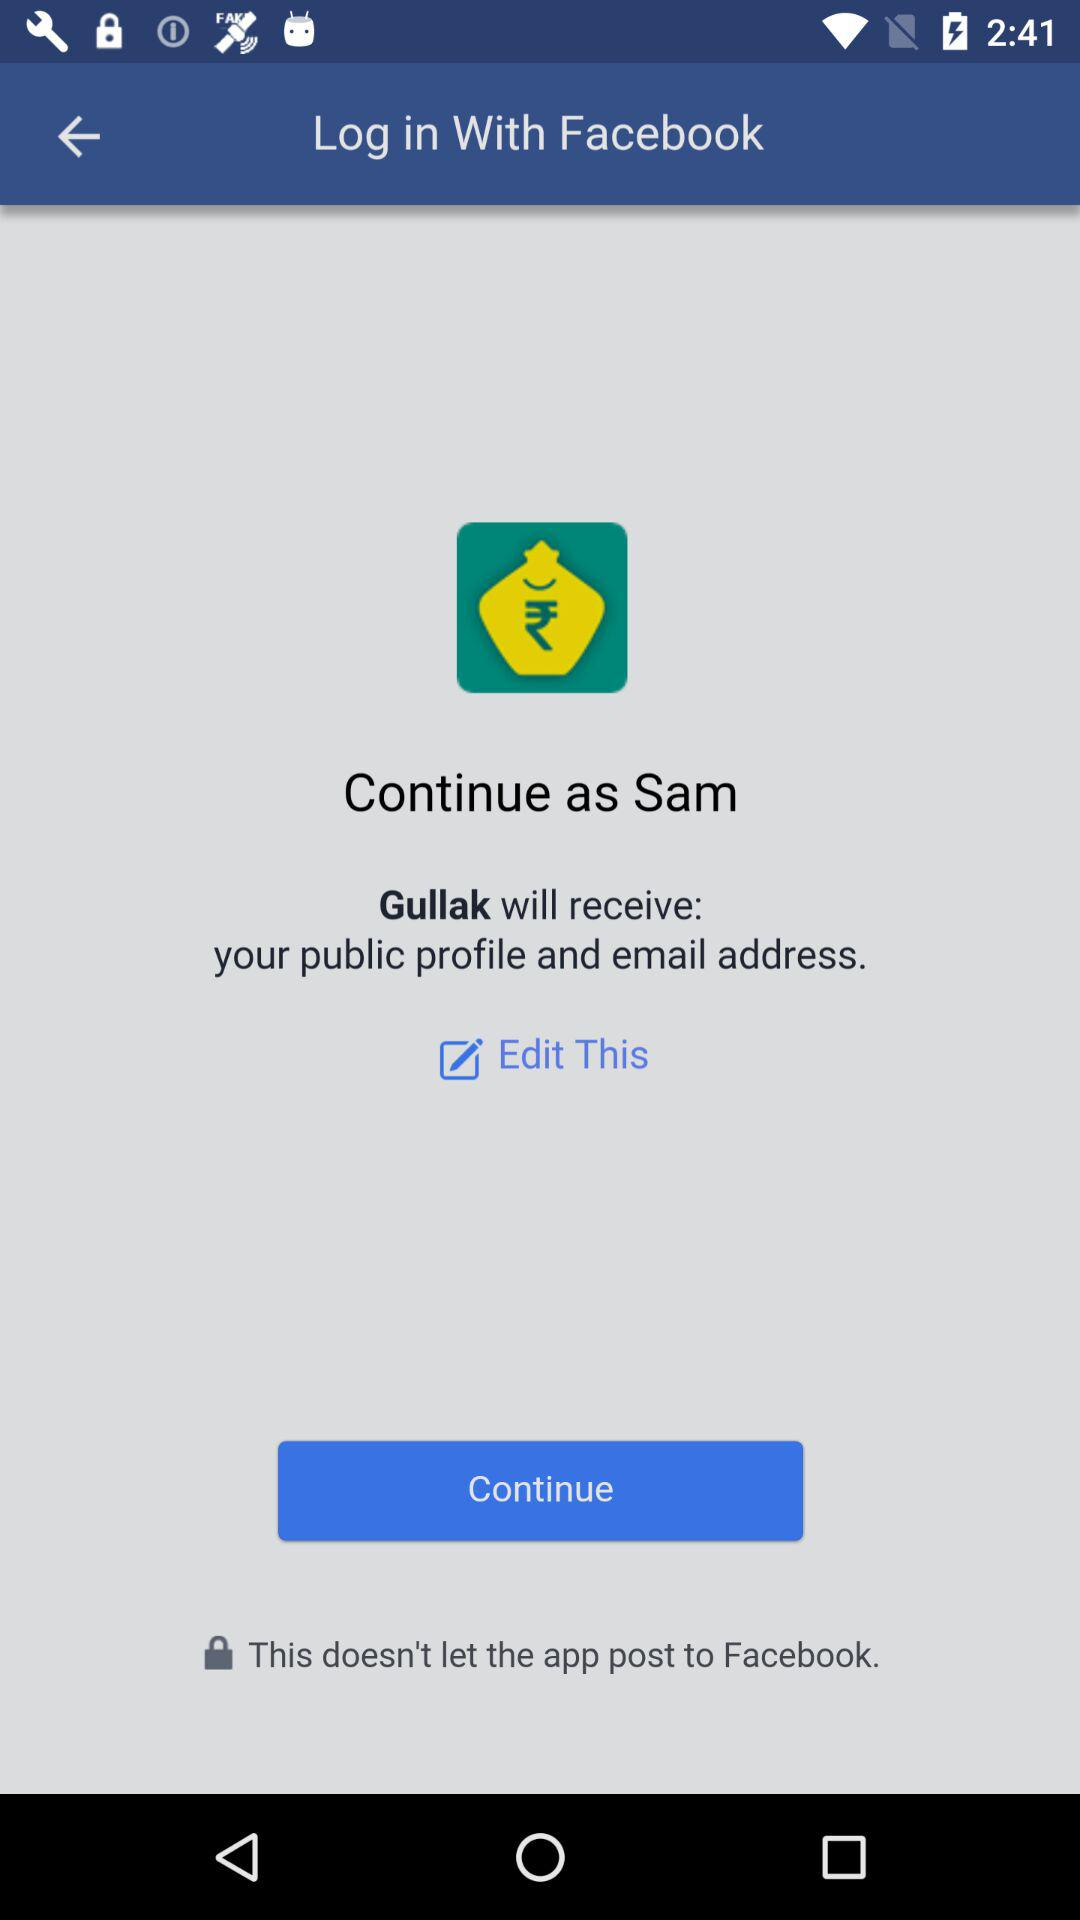What is the user name to continue the profile? The user name is Sam. 